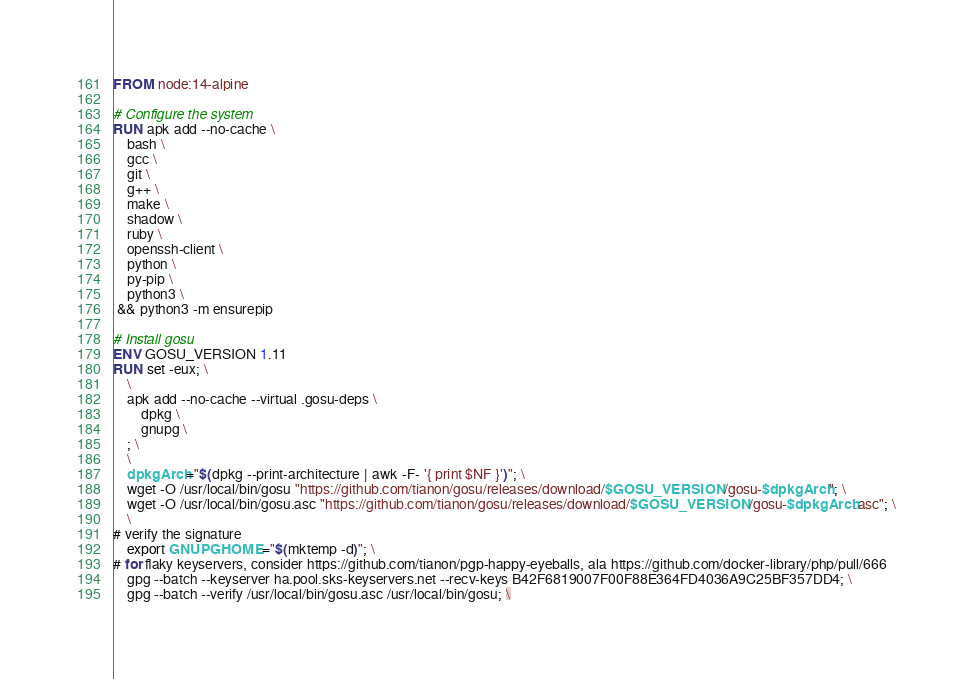Convert code to text. <code><loc_0><loc_0><loc_500><loc_500><_Dockerfile_>FROM node:14-alpine

# Configure the system
RUN apk add --no-cache \
    bash \
    gcc \
    git \
    g++ \
    make \
    shadow \
    ruby \
    openssh-client \
    python \
    py-pip \
    python3 \
 && python3 -m ensurepip

# Install gosu
ENV GOSU_VERSION 1.11
RUN set -eux; \
	\
	apk add --no-cache --virtual .gosu-deps \
		dpkg \
		gnupg \
	; \
	\
	dpkgArch="$(dpkg --print-architecture | awk -F- '{ print $NF }')"; \
	wget -O /usr/local/bin/gosu "https://github.com/tianon/gosu/releases/download/$GOSU_VERSION/gosu-$dpkgArch"; \
	wget -O /usr/local/bin/gosu.asc "https://github.com/tianon/gosu/releases/download/$GOSU_VERSION/gosu-$dpkgArch.asc"; \
	\
# verify the signature
	export GNUPGHOME="$(mktemp -d)"; \
# for flaky keyservers, consider https://github.com/tianon/pgp-happy-eyeballs, ala https://github.com/docker-library/php/pull/666
	gpg --batch --keyserver ha.pool.sks-keyservers.net --recv-keys B42F6819007F00F88E364FD4036A9C25BF357DD4; \
	gpg --batch --verify /usr/local/bin/gosu.asc /usr/local/bin/gosu; \</code> 